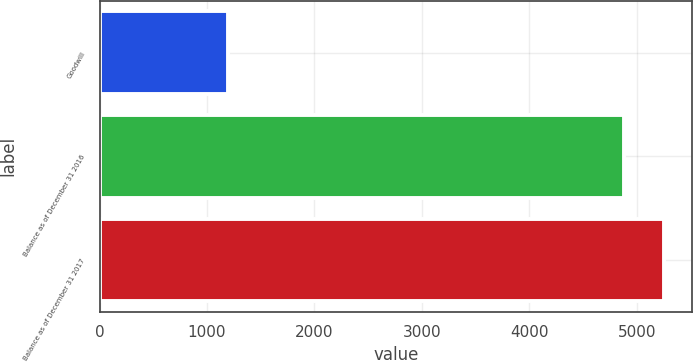Convert chart. <chart><loc_0><loc_0><loc_500><loc_500><bar_chart><fcel>Goodwill<fcel>Balance as of December 31 2016<fcel>Balance as of December 31 2017<nl><fcel>1194<fcel>4883<fcel>5251.9<nl></chart> 